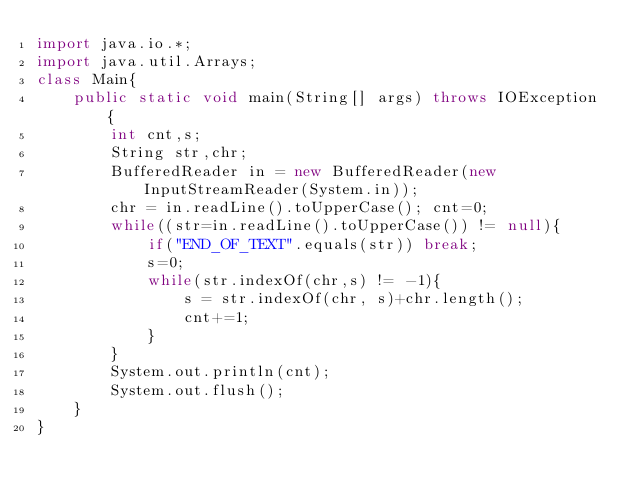<code> <loc_0><loc_0><loc_500><loc_500><_Java_>import java.io.*;
import java.util.Arrays;
class Main{
    public static void main(String[] args) throws IOException {
        int cnt,s; 
        String str,chr;
        BufferedReader in = new BufferedReader(new InputStreamReader(System.in));
        chr = in.readLine().toUpperCase(); cnt=0;
        while((str=in.readLine().toUpperCase()) != null){
            if("END_OF_TEXT".equals(str)) break;
            s=0;
            while(str.indexOf(chr,s) != -1){
                s = str.indexOf(chr, s)+chr.length();
                cnt+=1;
            }
        }
        System.out.println(cnt);
        System.out.flush();
    }
}</code> 